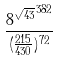Convert formula to latex. <formula><loc_0><loc_0><loc_500><loc_500>\frac { { 8 ^ { \sqrt { 4 3 } } } ^ { 3 8 2 } } { ( \frac { 2 1 5 } { 4 3 0 } ) ^ { 7 2 } }</formula> 